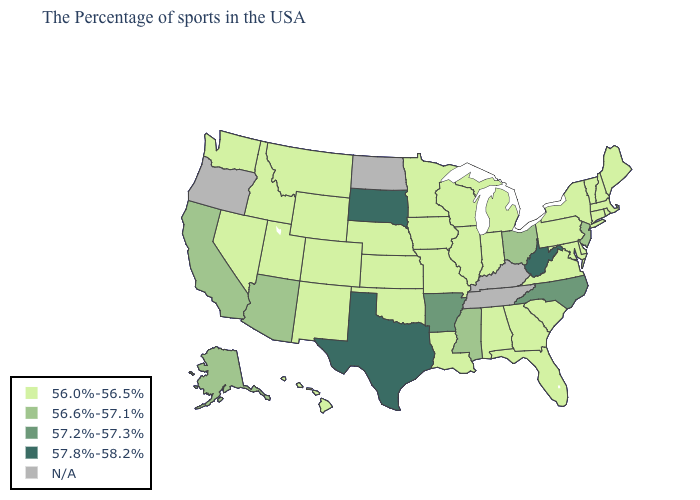Does Utah have the highest value in the West?
Short answer required. No. Does the map have missing data?
Write a very short answer. Yes. Does the map have missing data?
Give a very brief answer. Yes. Among the states that border Indiana , does Ohio have the lowest value?
Short answer required. No. Name the states that have a value in the range 57.8%-58.2%?
Quick response, please. West Virginia, Texas, South Dakota. What is the lowest value in the USA?
Short answer required. 56.0%-56.5%. What is the value of Iowa?
Be succinct. 56.0%-56.5%. What is the value of Arizona?
Answer briefly. 56.6%-57.1%. What is the value of Maryland?
Concise answer only. 56.0%-56.5%. What is the value of Arizona?
Concise answer only. 56.6%-57.1%. What is the value of Nevada?
Short answer required. 56.0%-56.5%. Name the states that have a value in the range 56.0%-56.5%?
Keep it brief. Maine, Massachusetts, Rhode Island, New Hampshire, Vermont, Connecticut, New York, Delaware, Maryland, Pennsylvania, Virginia, South Carolina, Florida, Georgia, Michigan, Indiana, Alabama, Wisconsin, Illinois, Louisiana, Missouri, Minnesota, Iowa, Kansas, Nebraska, Oklahoma, Wyoming, Colorado, New Mexico, Utah, Montana, Idaho, Nevada, Washington, Hawaii. Among the states that border Missouri , does Arkansas have the lowest value?
Quick response, please. No. 